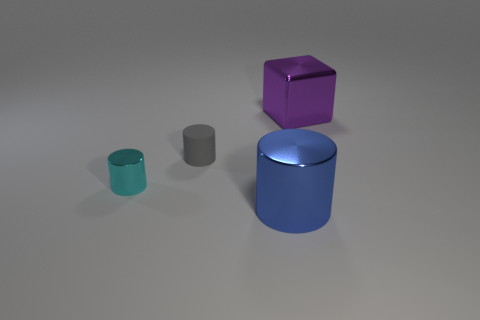Add 4 small brown balls. How many objects exist? 8 Subtract all cylinders. How many objects are left? 1 Add 3 large purple cubes. How many large purple cubes are left? 4 Add 1 tiny purple matte blocks. How many tiny purple matte blocks exist? 1 Subtract 1 gray cylinders. How many objects are left? 3 Subtract all blue cylinders. Subtract all small objects. How many objects are left? 1 